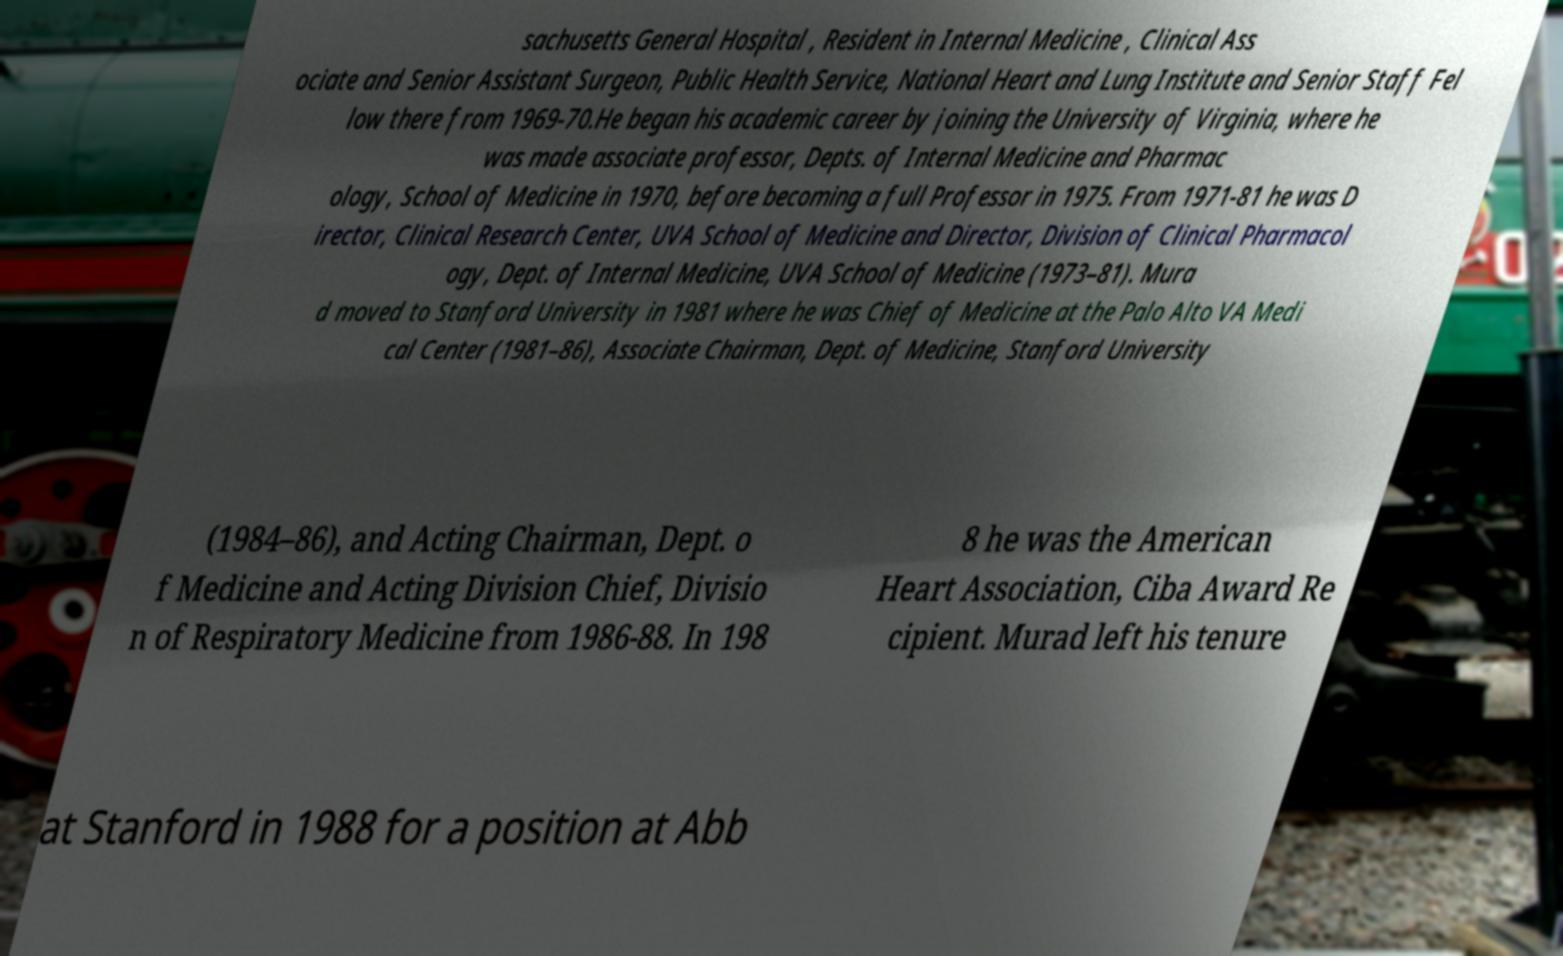Could you extract and type out the text from this image? sachusetts General Hospital , Resident in Internal Medicine , Clinical Ass ociate and Senior Assistant Surgeon, Public Health Service, National Heart and Lung Institute and Senior Staff Fel low there from 1969-70.He began his academic career by joining the University of Virginia, where he was made associate professor, Depts. of Internal Medicine and Pharmac ology, School of Medicine in 1970, before becoming a full Professor in 1975. From 1971-81 he was D irector, Clinical Research Center, UVA School of Medicine and Director, Division of Clinical Pharmacol ogy, Dept. of Internal Medicine, UVA School of Medicine (1973–81). Mura d moved to Stanford University in 1981 where he was Chief of Medicine at the Palo Alto VA Medi cal Center (1981–86), Associate Chairman, Dept. of Medicine, Stanford University (1984–86), and Acting Chairman, Dept. o f Medicine and Acting Division Chief, Divisio n of Respiratory Medicine from 1986-88. In 198 8 he was the American Heart Association, Ciba Award Re cipient. Murad left his tenure at Stanford in 1988 for a position at Abb 